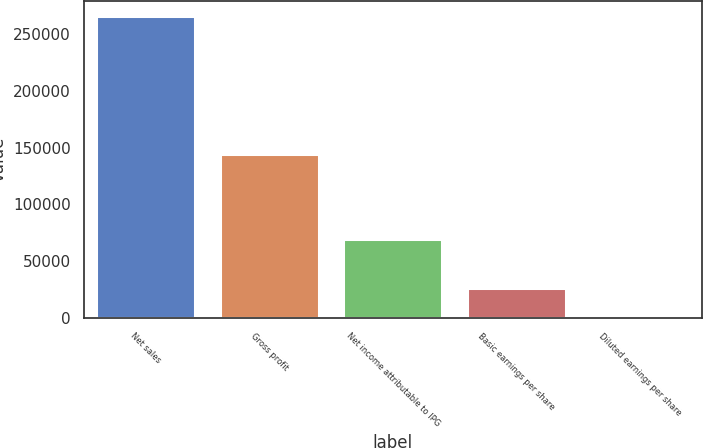<chart> <loc_0><loc_0><loc_500><loc_500><bar_chart><fcel>Net sales<fcel>Gross profit<fcel>Net income attributable to IPG<fcel>Basic earnings per share<fcel>Diluted earnings per share<nl><fcel>266017<fcel>144791<fcel>69235<fcel>26602.9<fcel>1.29<nl></chart> 